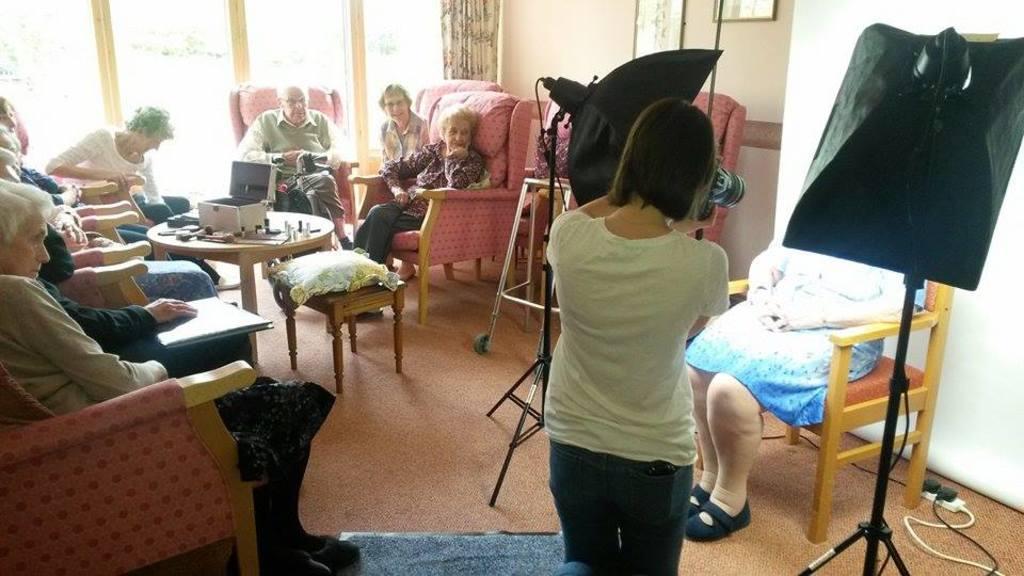Could you give a brief overview of what you see in this image? In this image I can see there are group of people who are sitting in a chair in front of the table. On the table we have few objects on it. The person on the right side is taking a photo. 